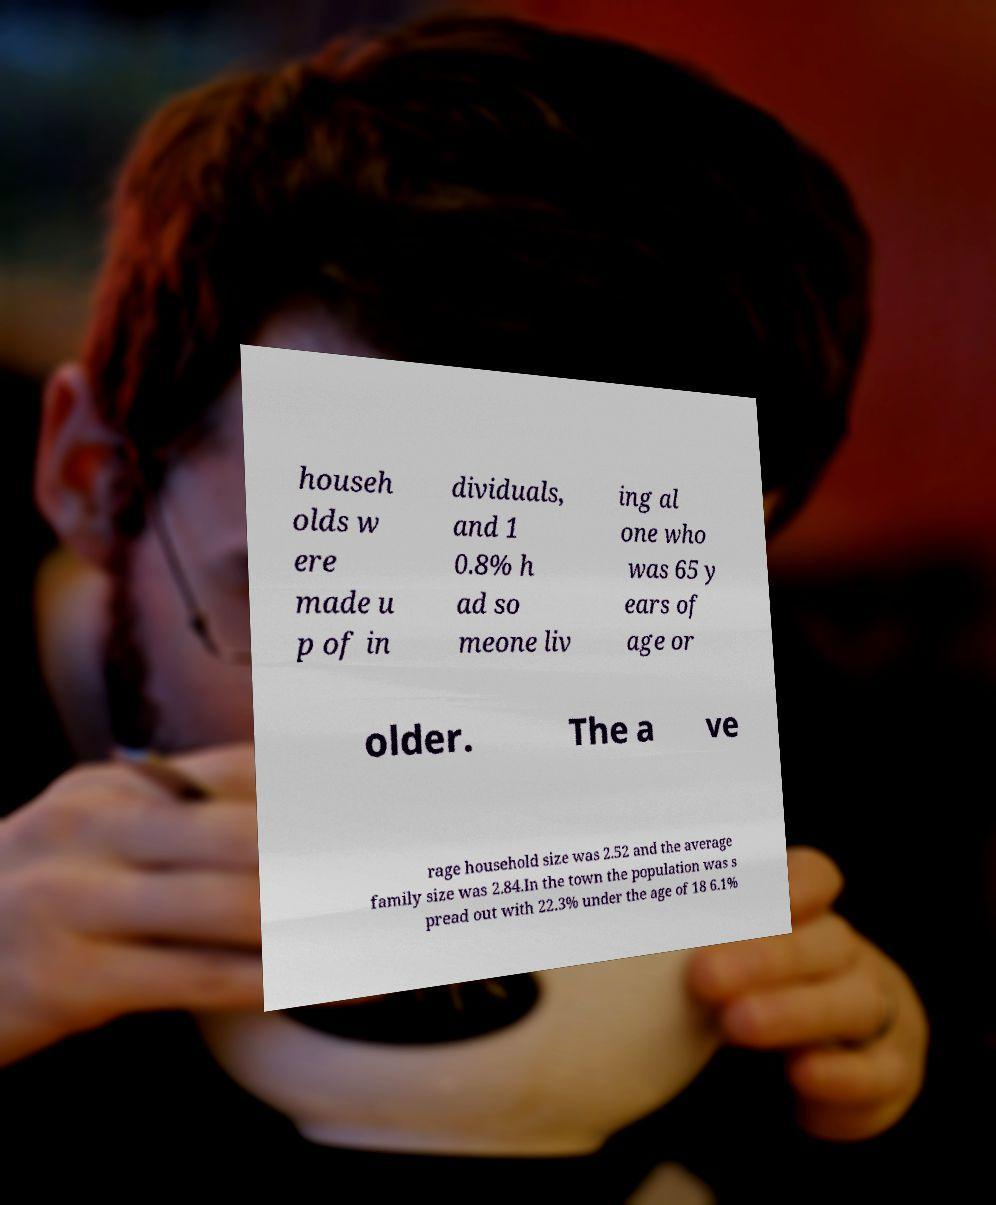I need the written content from this picture converted into text. Can you do that? househ olds w ere made u p of in dividuals, and 1 0.8% h ad so meone liv ing al one who was 65 y ears of age or older. The a ve rage household size was 2.52 and the average family size was 2.84.In the town the population was s pread out with 22.3% under the age of 18 6.1% 